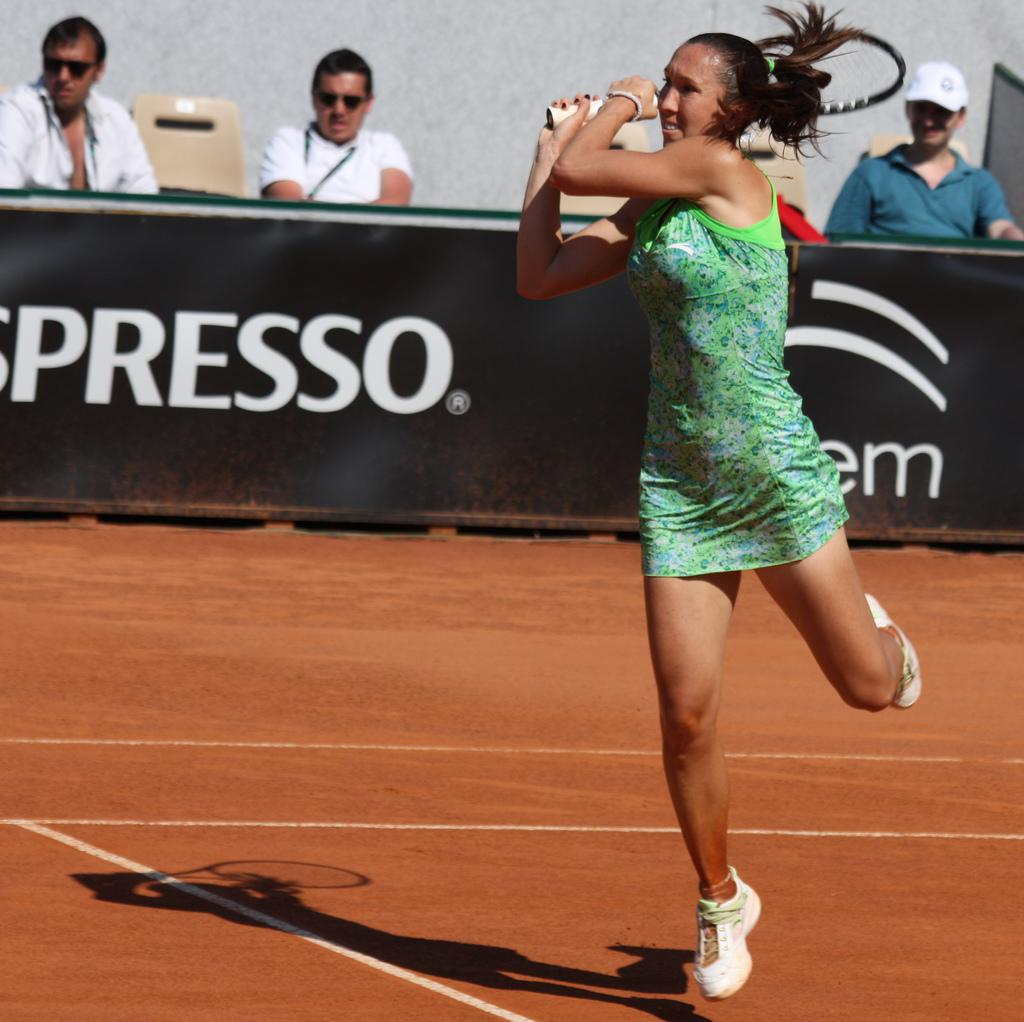Question: who is wearing a teal short sleeved shirt?
Choices:
A. The bartender at the bar.
B. The guy at the picnic.
C. The man wearing a white hat.
D. The woman handing out flier.
Answer with the letter. Answer: C Question: what is brown?
Choices:
A. The tennis players hair.
B. The dog.
C. The horse.
D. The cat.
Answer with the letter. Answer: A Question: how do we know its a sunny day?
Choices:
A. Because we can see a shadow of the tennis player.
B. Because people are wearing shades.
C. Because people are squinting.
D. People are wearing tank tops.
Answer with the letter. Answer: A Question: what on the wall is black with white writing?
Choices:
A. The advertisement.
B. The poster.
C. The painting.
D. The flier.
Answer with the letter. Answer: A Question: who is smiling in the background?
Choices:
A. The baby on the woman's lap.
B. The singer as she accepts award.
C. The person in the white hat and a blue shirt.
D. The dancer.
Answer with the letter. Answer: C Question: what sport is the woman playing?
Choices:
A. Bowling.
B. Tennis.
C. Soccer.
D. Basketball.
Answer with the letter. Answer: B Question: what kind of sport is this?
Choices:
A. Baseball.
B. Tennis.
C. Basketball.
D. Football.
Answer with the letter. Answer: B Question: what type of swing did she just make?
Choices:
A. Forehand.
B. Back hand.
C. Serve.
D. Lob.
Answer with the letter. Answer: B Question: why is your hair in a ponytail?
Choices:
A. Too hot.
B. Too long.
C. No distractions.
D. Looks pretty.
Answer with the letter. Answer: C Question: who do you want to challenge?
Choices:
A. Maria Sharapova.
B. Serena williams.
C. Venus Williams.
D. Martina Hingis.
Answer with the letter. Answer: B Question: who is in mid jump?
Choices:
A. The football player.
B. The basketball player.
C. The tennis player.
D. The pole vaulter.
Answer with the letter. Answer: C Question: where is this scene happening?
Choices:
A. Basketball game.
B. Soccer pitch.
C. Tennis court.
D. Baseball field.
Answer with the letter. Answer: C Question: what is the tennis player doing?
Choices:
A. Stretching.
B. Swinging her racquet.
C. Practicing.
D. Running.
Answer with the letter. Answer: B Question: whose hair is tied in a ponytail?
Choices:
A. The little girl.
B. The woman's.
C. The toddler.
D. The teeanger.
Answer with the letter. Answer: B Question: what gender is the tennis player?
Choices:
A. A male.
B. A female.
C. Girl.
D. Boy.
Answer with the letter. Answer: B Question: who is wearing a green dress?
Choices:
A. The spectator.
B. The coack.
C. The tennis player.
D. The judge.
Answer with the letter. Answer: C Question: what color is the tennis court?
Choices:
A. Green.
B. Red.
C. Brown.
D. Blue.
Answer with the letter. Answer: C 